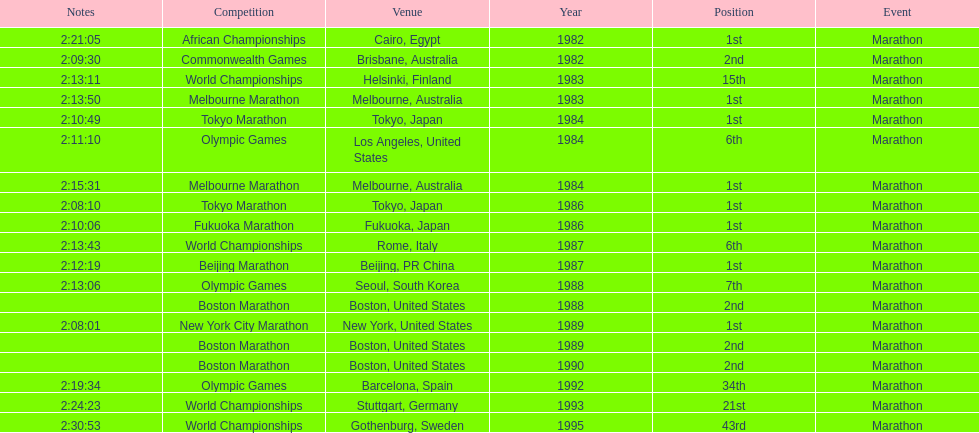In what year was the runner involved in the maximum marathons? 1984. 